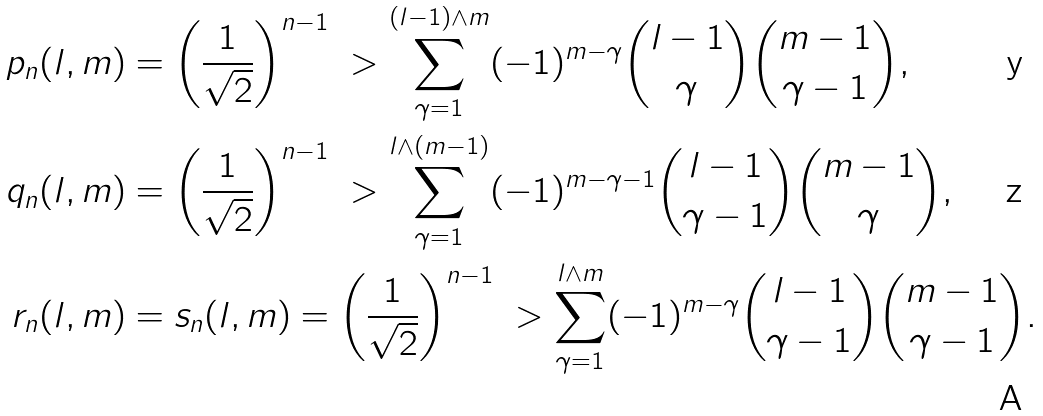Convert formula to latex. <formula><loc_0><loc_0><loc_500><loc_500>p _ { n } ( l , m ) & = \left ( \frac { 1 } { \sqrt { 2 } } \right ) ^ { n - 1 } \ > \sum _ { \gamma = 1 } ^ { ( l - 1 ) \wedge m } ( - 1 ) ^ { m - \gamma } { l - 1 \choose \gamma } { m - 1 \choose \gamma - 1 } , \\ q _ { n } ( l , m ) & = \left ( \frac { 1 } { \sqrt { 2 } } \right ) ^ { n - 1 } \ > \sum _ { \gamma = 1 } ^ { l \wedge ( m - 1 ) } ( - 1 ) ^ { m - \gamma - 1 } { l - 1 \choose \gamma - 1 } { m - 1 \choose \gamma } , \\ r _ { n } ( l , m ) & = s _ { n } ( l , m ) = \left ( \frac { 1 } { \sqrt { 2 } } \right ) ^ { n - 1 } \ > \sum _ { \gamma = 1 } ^ { l \wedge m } ( - 1 ) ^ { m - \gamma } { l - 1 \choose \gamma - 1 } { m - 1 \choose \gamma - 1 } .</formula> 